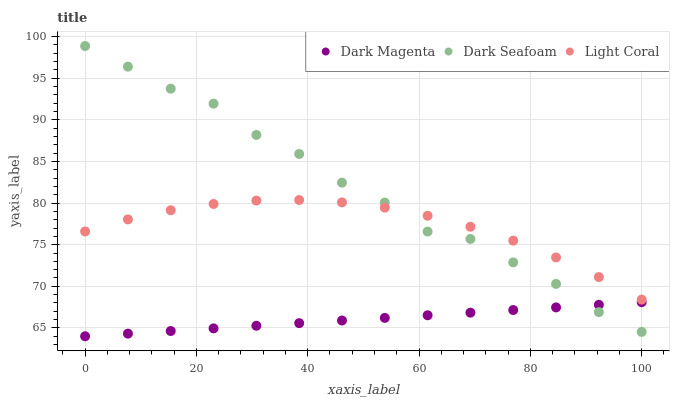Does Dark Magenta have the minimum area under the curve?
Answer yes or no. Yes. Does Dark Seafoam have the maximum area under the curve?
Answer yes or no. Yes. Does Dark Seafoam have the minimum area under the curve?
Answer yes or no. No. Does Dark Magenta have the maximum area under the curve?
Answer yes or no. No. Is Dark Magenta the smoothest?
Answer yes or no. Yes. Is Dark Seafoam the roughest?
Answer yes or no. Yes. Is Dark Seafoam the smoothest?
Answer yes or no. No. Is Dark Magenta the roughest?
Answer yes or no. No. Does Dark Magenta have the lowest value?
Answer yes or no. Yes. Does Dark Seafoam have the lowest value?
Answer yes or no. No. Does Dark Seafoam have the highest value?
Answer yes or no. Yes. Does Dark Magenta have the highest value?
Answer yes or no. No. Is Dark Magenta less than Light Coral?
Answer yes or no. Yes. Is Light Coral greater than Dark Magenta?
Answer yes or no. Yes. Does Dark Magenta intersect Dark Seafoam?
Answer yes or no. Yes. Is Dark Magenta less than Dark Seafoam?
Answer yes or no. No. Is Dark Magenta greater than Dark Seafoam?
Answer yes or no. No. Does Dark Magenta intersect Light Coral?
Answer yes or no. No. 